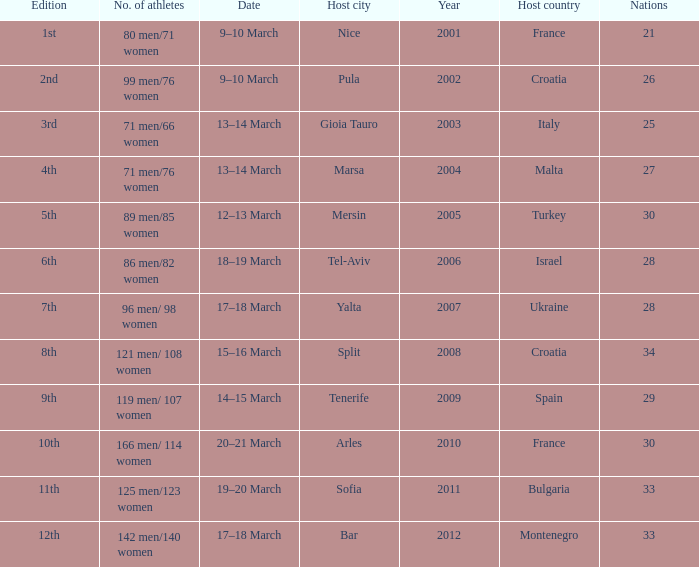What was the number of athletes in the host city of Nice? 80 men/71 women. 